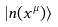Convert formula to latex. <formula><loc_0><loc_0><loc_500><loc_500>| n ( x ^ { \mu } ) \rangle</formula> 